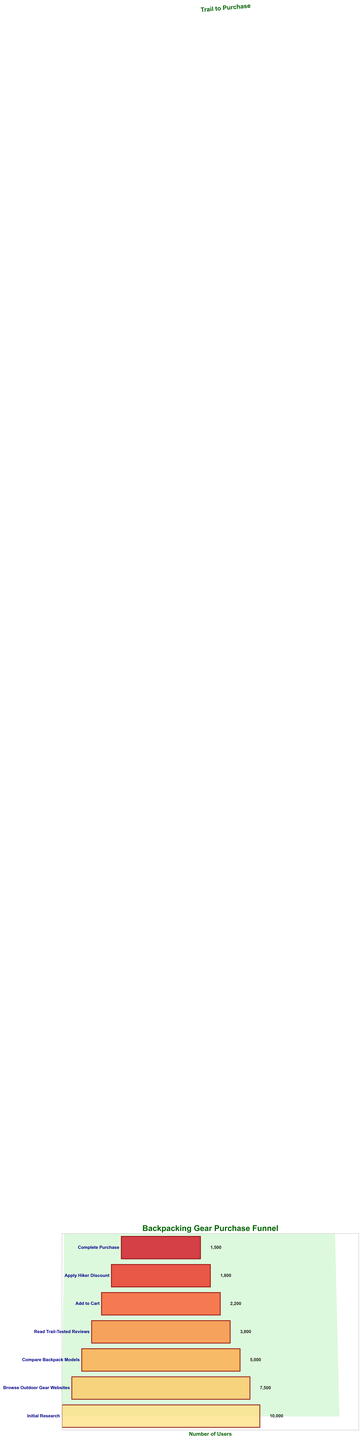What's the title of the chart? The title is prominently displayed at the top of the chart.
Answer: Backpacking Gear Purchase Funnel How many stages are there in the funnel? The stages are listed vertically on the left side of the funnel. There are seven stages in total from "Initial Research" to "Complete Purchase".
Answer: Seven What is the number of users who completed the purchase? Look at the rightmost text corresponding to the "Complete Purchase" stage. It shows the number of users at this stage.
Answer: 1500 How many users dropped out between "Read Trail-Tested Reviews" and "Add to Cart" stages? Subtract the user count at "Add to Cart" (2200) from the user count at "Read Trail-Tested Reviews" (3800).
Answer: 1600 Which stage had the highest drop-off rate in absolute user numbers? The drop-off rate can be calculated by the difference in users between each consecutive stage. The highest difference is between "Read Trail-Tested Reviews" (3800) and "Add to Cart" (2200), which is a drop-off of 1600 users.
Answer: From "Read Trail-Tested Reviews" to "Add to Cart" Compare the number of users who applied the hiker discount to those who completed the purchase. The users who applied the hiker discount is 1800, and those who completed the purchase is 1500. 1800 is greater than 1500.
Answer: More users applied the hiker discount than completed the purchase What is the percentage of users who went from "Initial Research" to "Complete Purchase"? To find the percentage, divide the number of users at "Complete Purchase" (1500) by the number of users at "Initial Research" (10000), and then multiply by 100. The calculation is (1500 / 10000) * 100 = 15%.
Answer: 15% Which stage had the smallest number of users after "Read Trail-Tested Reviews"? Compare the user counts at each stage after "Read Trail-Tested Reviews". The smallest number is at "Complete Purchase" with 1500 users.
Answer: Complete Purchase By how much did the number of users decrease from "Browse Outdoor Gear Websites" to "Compare Backpack Models"? Subtract the users at "Browse Outdoor Gear Websites" (7500) from those at "Compare Backpack Models" (5000). The calculation is 7500 - 5000 = 2500.
Answer: 2500 What visual element is used to indicate the stages in the funnel chart? The stage names are written next to horizontal bars at each level of the funnel, indicating the different stages.
Answer: Horizontal bars What color gradient is used in the funnel stages? The bars in the funnel chart use a gradient from yellowish to reddish colors as you move down the stages.
Answer: Yellow to red gradient 